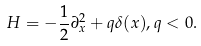Convert formula to latex. <formula><loc_0><loc_0><loc_500><loc_500>H = - \frac { 1 } { 2 } \partial _ { x } ^ { 2 } + q \delta ( x ) , q < 0 .</formula> 